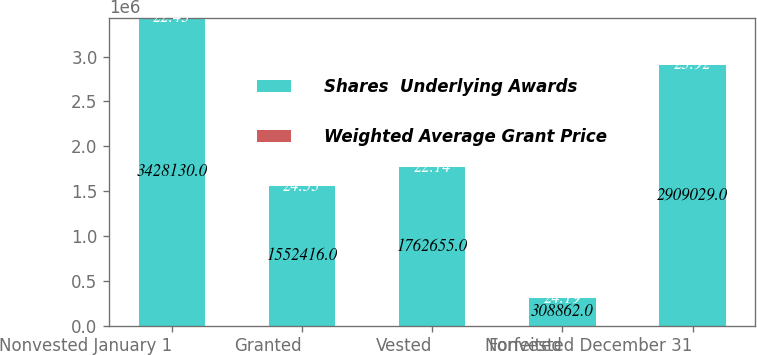<chart> <loc_0><loc_0><loc_500><loc_500><stacked_bar_chart><ecel><fcel>Nonvested January 1<fcel>Granted<fcel>Vested<fcel>Forfeited<fcel>Nonvested December 31<nl><fcel>Shares  Underlying Awards<fcel>3.42813e+06<fcel>1.55242e+06<fcel>1.76266e+06<fcel>308862<fcel>2.90903e+06<nl><fcel>Weighted Average Grant Price<fcel>22.43<fcel>24.53<fcel>22.14<fcel>24.19<fcel>23.92<nl></chart> 